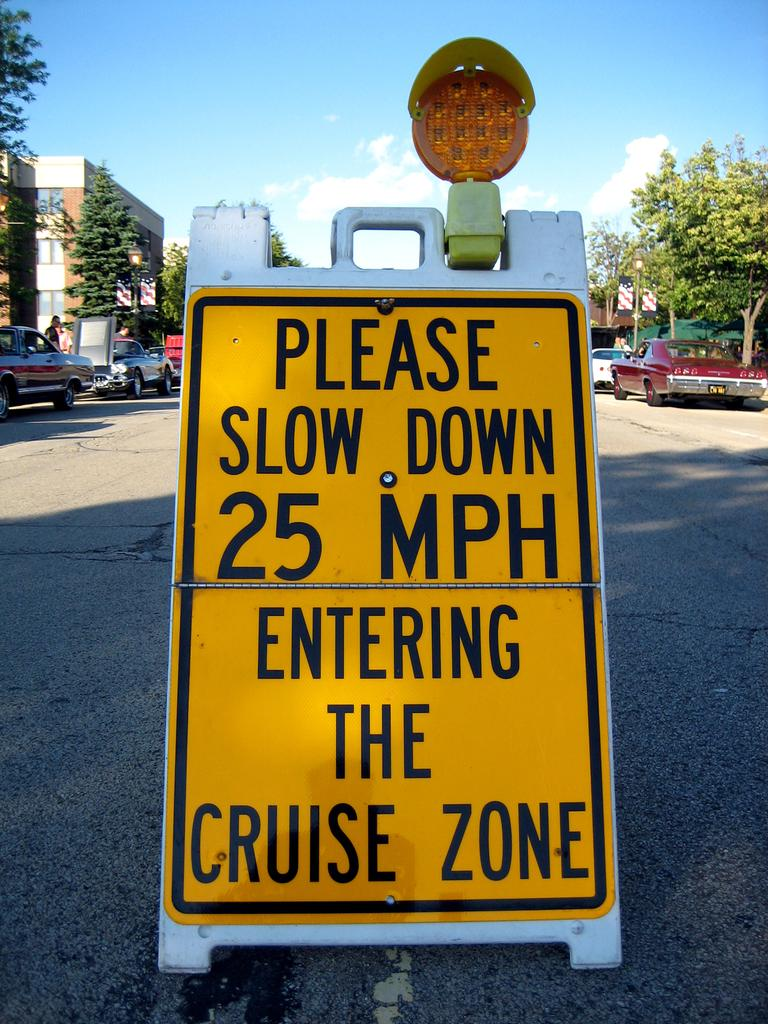<image>
Relay a brief, clear account of the picture shown. a sign that says to please slow down on it 